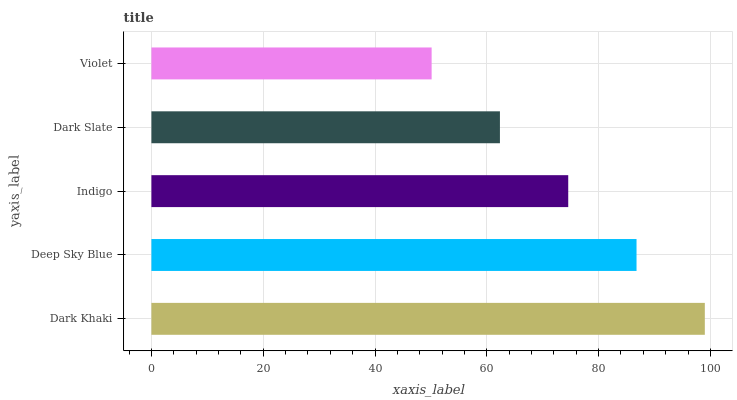Is Violet the minimum?
Answer yes or no. Yes. Is Dark Khaki the maximum?
Answer yes or no. Yes. Is Deep Sky Blue the minimum?
Answer yes or no. No. Is Deep Sky Blue the maximum?
Answer yes or no. No. Is Dark Khaki greater than Deep Sky Blue?
Answer yes or no. Yes. Is Deep Sky Blue less than Dark Khaki?
Answer yes or no. Yes. Is Deep Sky Blue greater than Dark Khaki?
Answer yes or no. No. Is Dark Khaki less than Deep Sky Blue?
Answer yes or no. No. Is Indigo the high median?
Answer yes or no. Yes. Is Indigo the low median?
Answer yes or no. Yes. Is Dark Slate the high median?
Answer yes or no. No. Is Dark Slate the low median?
Answer yes or no. No. 